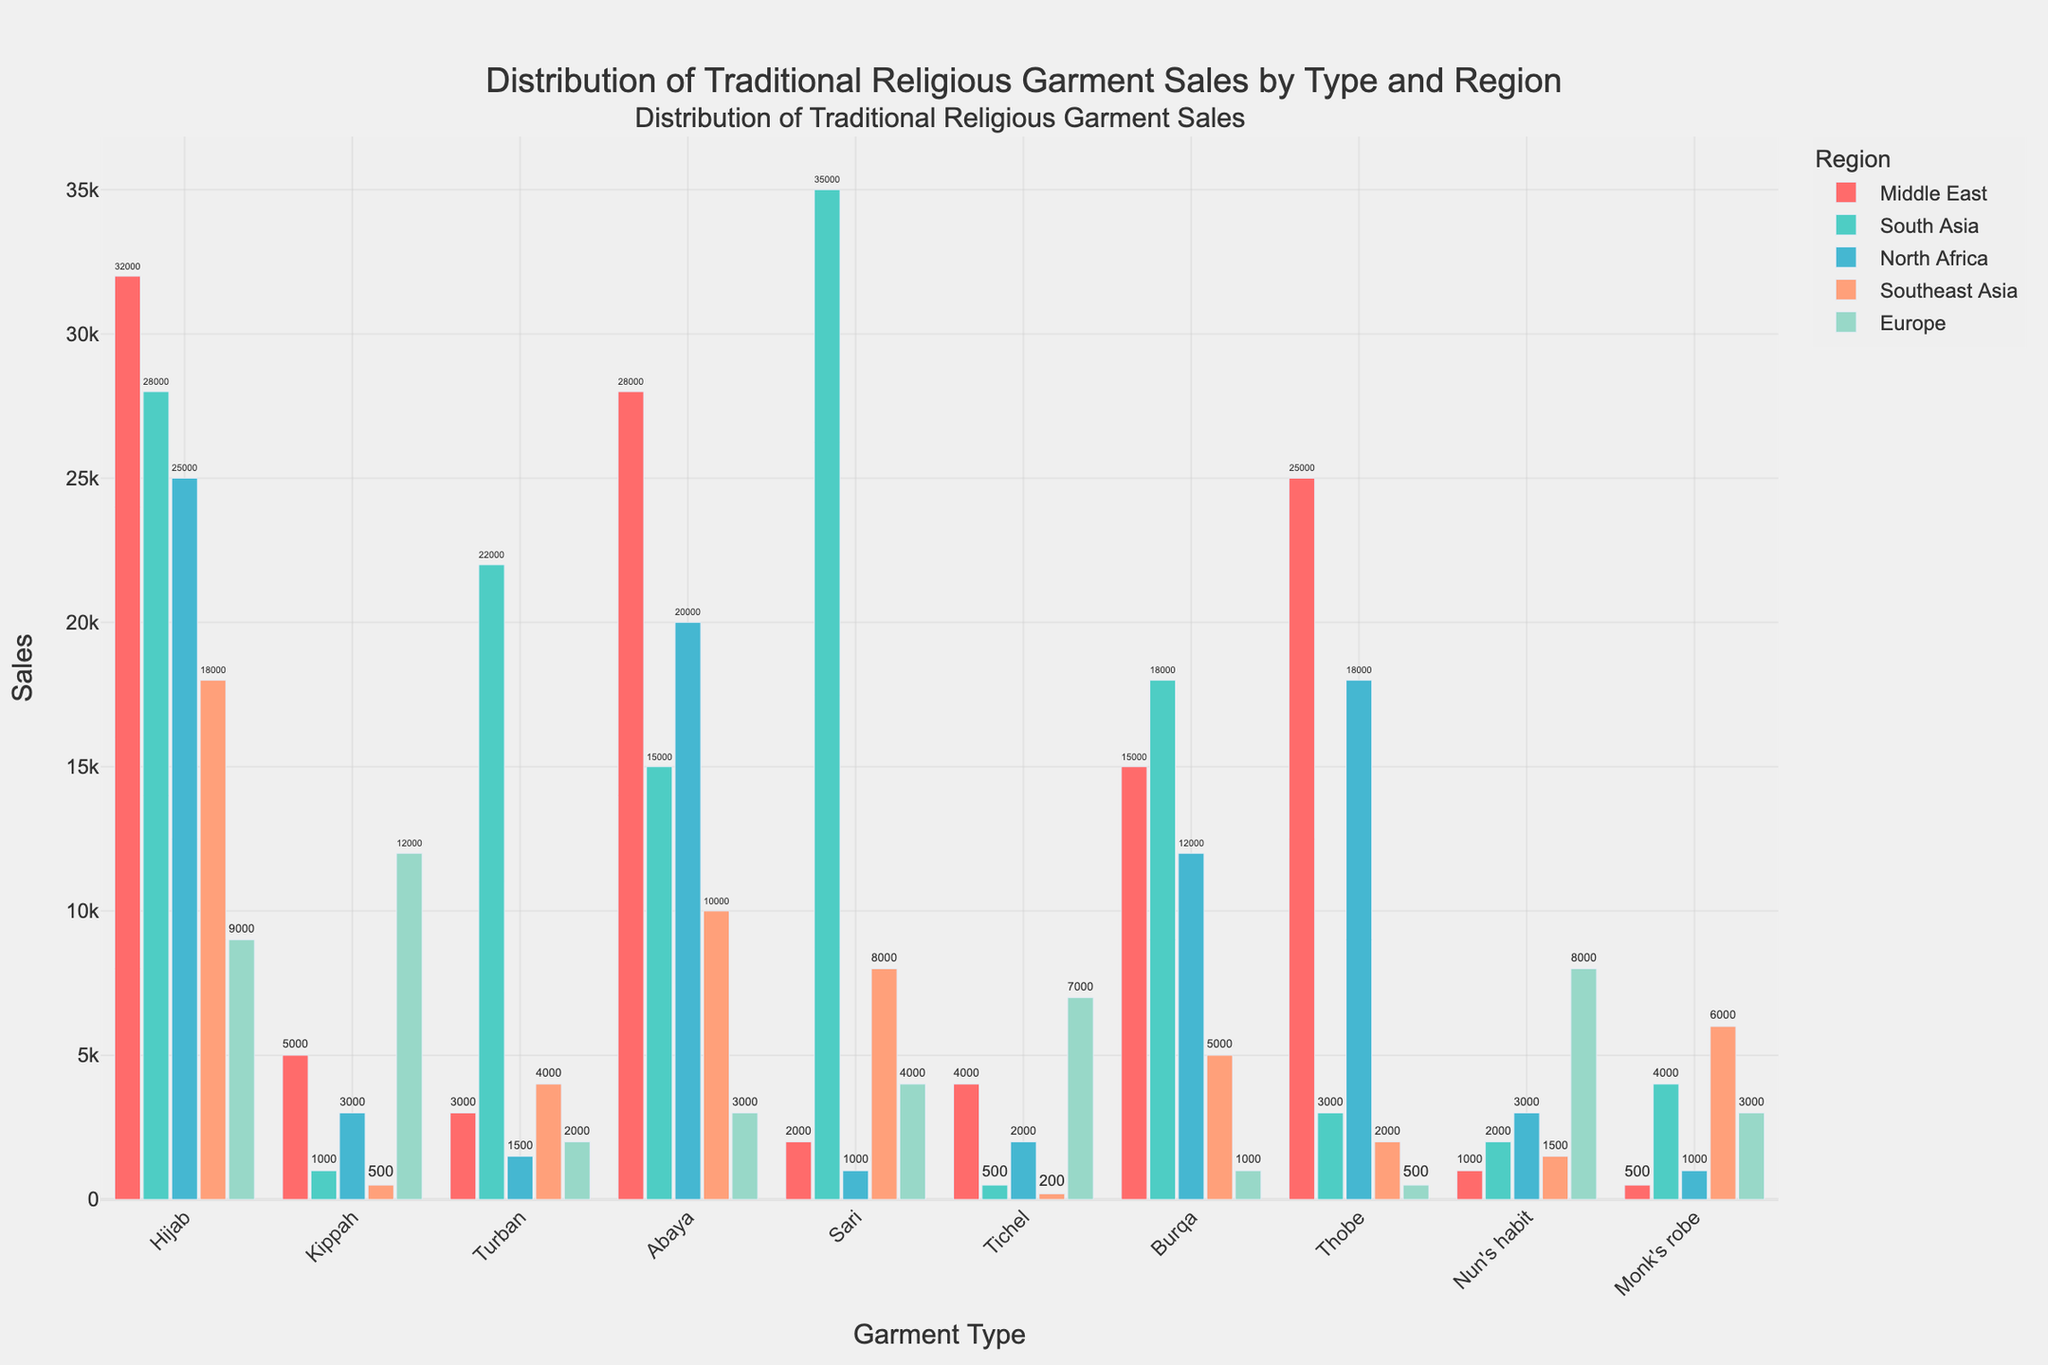Which region has the highest sales for the Hijab? By looking at the heights of the bars for each region under Hijab, the tallest bar indicates the region with the highest sales. Here, the Middle East bar is the tallest, indicating the highest sales.
Answer: Middle East Which garment type has the lowest sales in Southeast Asia? Check the bars under Southeast Asia for each garment type and identify the shortest one. The shortest bar is for Tichel.
Answer: Tichel What is the total sales of Turban across all regions? Sum the sales values for Turban across all regions: 3000 (Middle East) + 22000 (South Asia) + 1500 (North Africa) + 4000 (Southeast Asia) + 2000 (Europe) = 32500.
Answer: 32500 Which garment type has higher sales in Europe, Kippah or Nun's habit? Compare the heights of the bars for Kippah and Nun's habit under Europe. The bar for Kippah is taller.
Answer: Kippah What is the difference in sales of Abaya between the Middle East and Europe? Subtract the sales of Abaya in Europe from the sales in the Middle East: 28000 (Middle East) - 3000 (Europe) = 25000.
Answer: 25000 In which region does Burqa have higher sales than Sari? Compare the Burqa and Sari bars across all regions. In the Middle East, Burqa (15000) is higher than Sari (2000), in North Africa, Burqa (12000) is higher than Sari (1000), and in Southeast Asia, Burqa (5000) is higher than Sari (8000).
Answer: Middle East, North Africa Which two garment types have the closest sales figures in North Africa? Look at the heights of the bars under North Africa and find two that are close in height. The sales of Hijab (25000) and Abaya (20000) are closer than the others.
Answer: Hijab and Abaya What is the average sales of Hijab and Abaya in South Asia? Calculate the average by adding the sales of Hijab (28000) and Abaya (15000), then dividing by 2: (28000 + 15000)/2 = 21500.
Answer: 21500 Which region has the lowest sales for Nun's habit? Check the heights of the bars for Nun's habit across all regions and identify the shortest one. The shortest bar is for the Middle East.
Answer: Middle East How does the sales figure for Thobe in North Africa compare to Southeast Asia? Compare the heights of the bars for Thobe in North Africa (18000) and Southeast Asia (2000). Thobe sales in North Africa are higher.
Answer: Higher in North Africa 